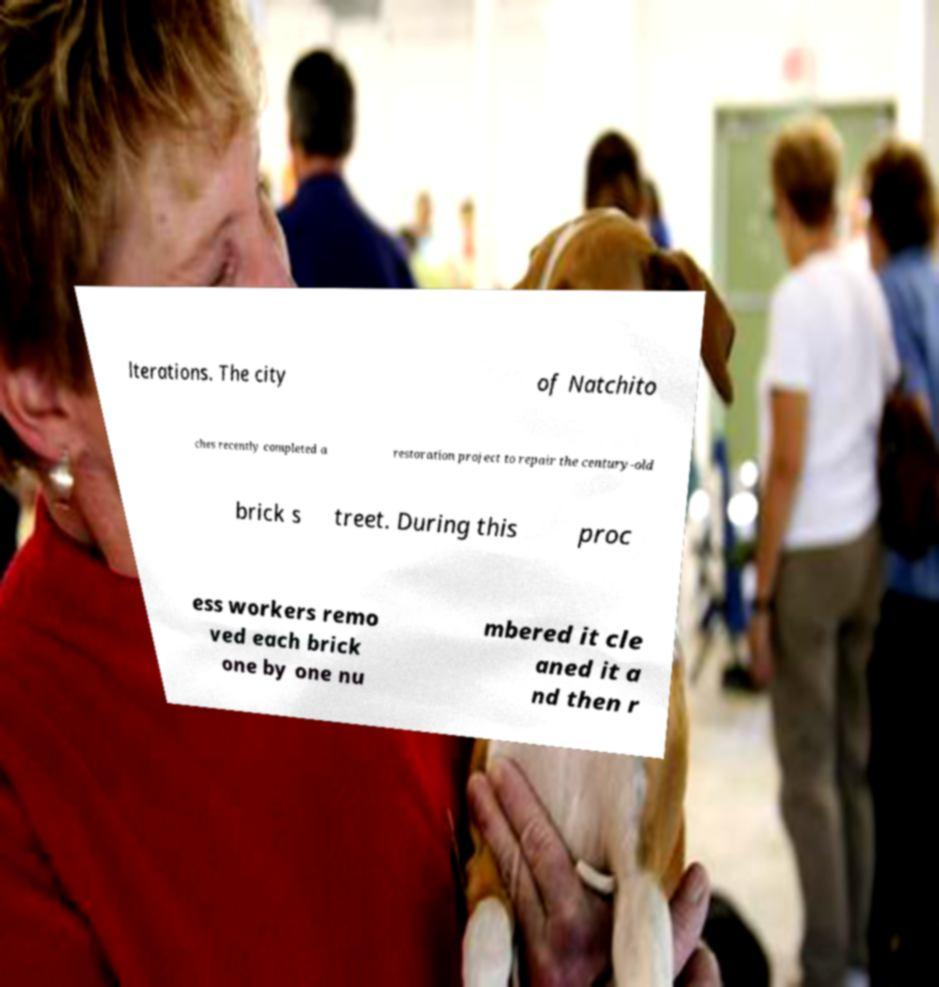Can you accurately transcribe the text from the provided image for me? lterations. The city of Natchito ches recently completed a restoration project to repair the century-old brick s treet. During this proc ess workers remo ved each brick one by one nu mbered it cle aned it a nd then r 